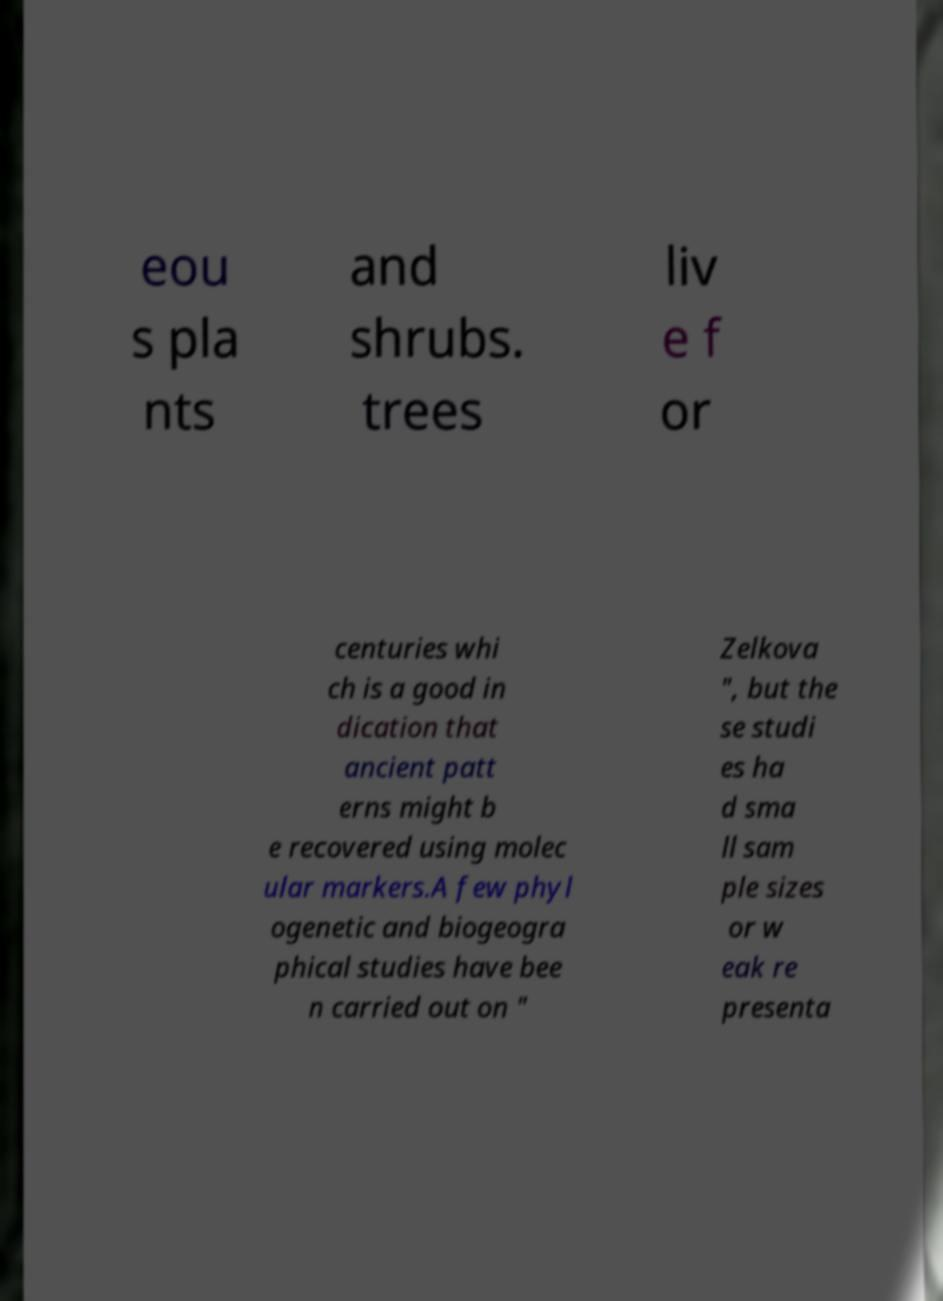Could you extract and type out the text from this image? eou s pla nts and shrubs. trees liv e f or centuries whi ch is a good in dication that ancient patt erns might b e recovered using molec ular markers.A few phyl ogenetic and biogeogra phical studies have bee n carried out on " Zelkova ", but the se studi es ha d sma ll sam ple sizes or w eak re presenta 